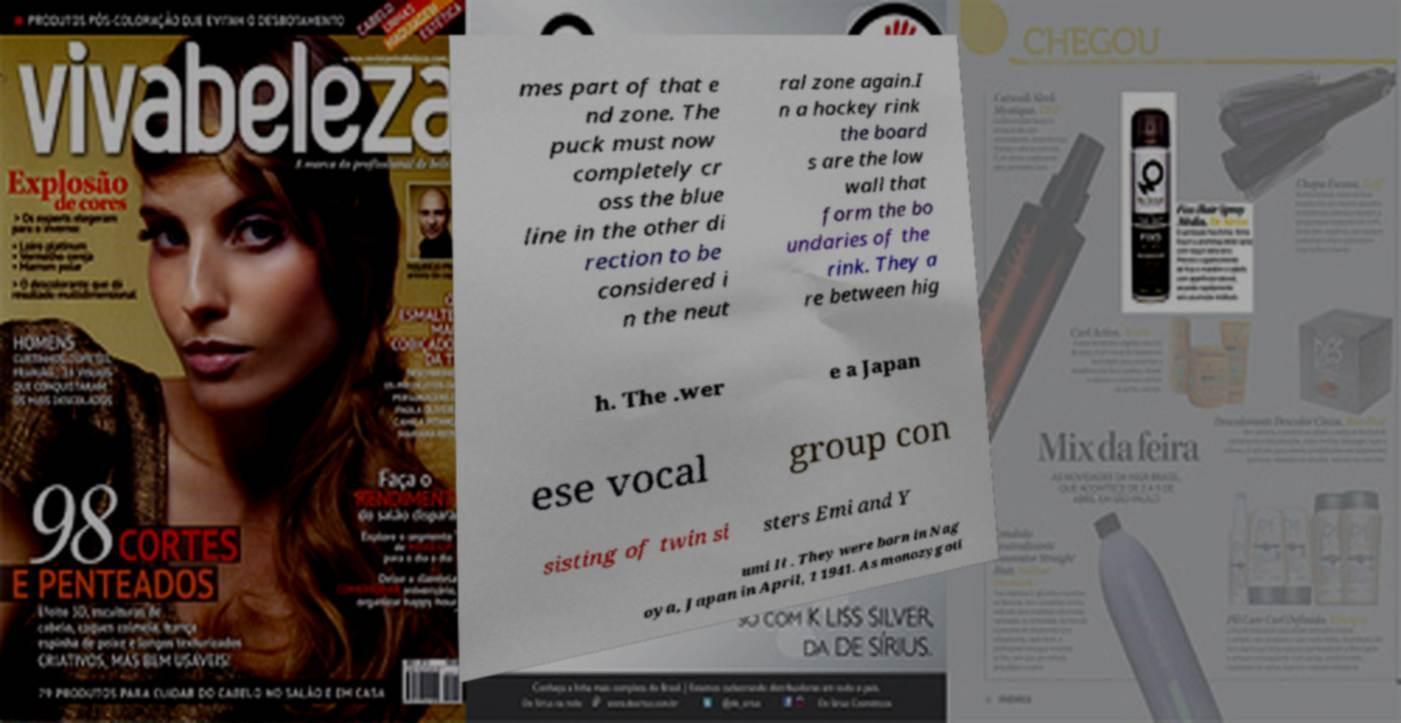Please identify and transcribe the text found in this image. mes part of that e nd zone. The puck must now completely cr oss the blue line in the other di rection to be considered i n the neut ral zone again.I n a hockey rink the board s are the low wall that form the bo undaries of the rink. They a re between hig h. The .wer e a Japan ese vocal group con sisting of twin si sters Emi and Y umi It . They were born in Nag oya, Japan in April, 1 1941. As monozygoti 